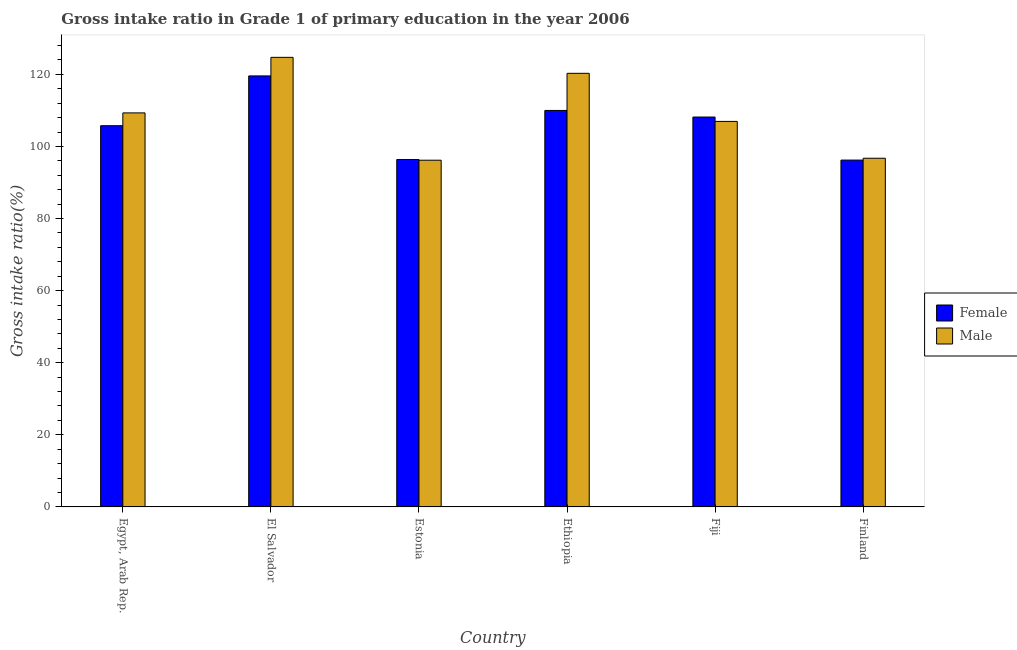How many different coloured bars are there?
Your answer should be very brief. 2. How many groups of bars are there?
Provide a short and direct response. 6. Are the number of bars per tick equal to the number of legend labels?
Provide a succinct answer. Yes. Are the number of bars on each tick of the X-axis equal?
Give a very brief answer. Yes. How many bars are there on the 5th tick from the left?
Offer a terse response. 2. How many bars are there on the 5th tick from the right?
Provide a succinct answer. 2. What is the label of the 1st group of bars from the left?
Give a very brief answer. Egypt, Arab Rep. What is the gross intake ratio(male) in Finland?
Keep it short and to the point. 96.73. Across all countries, what is the maximum gross intake ratio(male)?
Your answer should be very brief. 124.72. Across all countries, what is the minimum gross intake ratio(female)?
Provide a short and direct response. 96.22. In which country was the gross intake ratio(male) maximum?
Your answer should be very brief. El Salvador. In which country was the gross intake ratio(male) minimum?
Offer a very short reply. Estonia. What is the total gross intake ratio(male) in the graph?
Make the answer very short. 654.16. What is the difference between the gross intake ratio(male) in Egypt, Arab Rep. and that in Ethiopia?
Offer a terse response. -10.98. What is the difference between the gross intake ratio(male) in Finland and the gross intake ratio(female) in Egypt, Arab Rep.?
Your response must be concise. -9.03. What is the average gross intake ratio(male) per country?
Offer a terse response. 109.03. What is the difference between the gross intake ratio(female) and gross intake ratio(male) in Ethiopia?
Give a very brief answer. -10.3. In how many countries, is the gross intake ratio(male) greater than 12 %?
Provide a succinct answer. 6. What is the ratio of the gross intake ratio(female) in El Salvador to that in Estonia?
Your answer should be very brief. 1.24. Is the difference between the gross intake ratio(male) in Egypt, Arab Rep. and Estonia greater than the difference between the gross intake ratio(female) in Egypt, Arab Rep. and Estonia?
Your answer should be very brief. Yes. What is the difference between the highest and the second highest gross intake ratio(male)?
Your answer should be very brief. 4.43. What is the difference between the highest and the lowest gross intake ratio(male)?
Offer a very short reply. 28.54. Is the sum of the gross intake ratio(female) in El Salvador and Estonia greater than the maximum gross intake ratio(male) across all countries?
Offer a terse response. Yes. What does the 1st bar from the left in El Salvador represents?
Make the answer very short. Female. How many bars are there?
Your response must be concise. 12. How many countries are there in the graph?
Give a very brief answer. 6. Are the values on the major ticks of Y-axis written in scientific E-notation?
Provide a succinct answer. No. How are the legend labels stacked?
Make the answer very short. Vertical. What is the title of the graph?
Offer a very short reply. Gross intake ratio in Grade 1 of primary education in the year 2006. Does "Borrowers" appear as one of the legend labels in the graph?
Keep it short and to the point. No. What is the label or title of the Y-axis?
Your answer should be compact. Gross intake ratio(%). What is the Gross intake ratio(%) in Female in Egypt, Arab Rep.?
Offer a terse response. 105.75. What is the Gross intake ratio(%) of Male in Egypt, Arab Rep.?
Provide a short and direct response. 109.31. What is the Gross intake ratio(%) in Female in El Salvador?
Offer a very short reply. 119.57. What is the Gross intake ratio(%) in Male in El Salvador?
Offer a terse response. 124.72. What is the Gross intake ratio(%) of Female in Estonia?
Provide a succinct answer. 96.38. What is the Gross intake ratio(%) of Male in Estonia?
Give a very brief answer. 96.18. What is the Gross intake ratio(%) of Female in Ethiopia?
Provide a succinct answer. 109.99. What is the Gross intake ratio(%) of Male in Ethiopia?
Keep it short and to the point. 120.29. What is the Gross intake ratio(%) in Female in Fiji?
Ensure brevity in your answer.  108.16. What is the Gross intake ratio(%) in Male in Fiji?
Give a very brief answer. 106.95. What is the Gross intake ratio(%) in Female in Finland?
Provide a succinct answer. 96.22. What is the Gross intake ratio(%) in Male in Finland?
Your answer should be very brief. 96.73. Across all countries, what is the maximum Gross intake ratio(%) of Female?
Make the answer very short. 119.57. Across all countries, what is the maximum Gross intake ratio(%) of Male?
Offer a very short reply. 124.72. Across all countries, what is the minimum Gross intake ratio(%) in Female?
Keep it short and to the point. 96.22. Across all countries, what is the minimum Gross intake ratio(%) in Male?
Offer a terse response. 96.18. What is the total Gross intake ratio(%) in Female in the graph?
Your answer should be compact. 636.07. What is the total Gross intake ratio(%) in Male in the graph?
Keep it short and to the point. 654.16. What is the difference between the Gross intake ratio(%) of Female in Egypt, Arab Rep. and that in El Salvador?
Provide a short and direct response. -13.81. What is the difference between the Gross intake ratio(%) in Male in Egypt, Arab Rep. and that in El Salvador?
Offer a very short reply. -15.41. What is the difference between the Gross intake ratio(%) of Female in Egypt, Arab Rep. and that in Estonia?
Your answer should be very brief. 9.37. What is the difference between the Gross intake ratio(%) in Male in Egypt, Arab Rep. and that in Estonia?
Ensure brevity in your answer.  13.13. What is the difference between the Gross intake ratio(%) in Female in Egypt, Arab Rep. and that in Ethiopia?
Keep it short and to the point. -4.23. What is the difference between the Gross intake ratio(%) in Male in Egypt, Arab Rep. and that in Ethiopia?
Provide a short and direct response. -10.98. What is the difference between the Gross intake ratio(%) of Female in Egypt, Arab Rep. and that in Fiji?
Give a very brief answer. -2.4. What is the difference between the Gross intake ratio(%) in Male in Egypt, Arab Rep. and that in Fiji?
Give a very brief answer. 2.36. What is the difference between the Gross intake ratio(%) in Female in Egypt, Arab Rep. and that in Finland?
Keep it short and to the point. 9.54. What is the difference between the Gross intake ratio(%) of Male in Egypt, Arab Rep. and that in Finland?
Offer a very short reply. 12.58. What is the difference between the Gross intake ratio(%) in Female in El Salvador and that in Estonia?
Your answer should be compact. 23.19. What is the difference between the Gross intake ratio(%) in Male in El Salvador and that in Estonia?
Keep it short and to the point. 28.54. What is the difference between the Gross intake ratio(%) in Female in El Salvador and that in Ethiopia?
Offer a terse response. 9.58. What is the difference between the Gross intake ratio(%) of Male in El Salvador and that in Ethiopia?
Make the answer very short. 4.43. What is the difference between the Gross intake ratio(%) of Female in El Salvador and that in Fiji?
Keep it short and to the point. 11.41. What is the difference between the Gross intake ratio(%) in Male in El Salvador and that in Fiji?
Offer a terse response. 17.77. What is the difference between the Gross intake ratio(%) of Female in El Salvador and that in Finland?
Your answer should be compact. 23.35. What is the difference between the Gross intake ratio(%) of Male in El Salvador and that in Finland?
Provide a short and direct response. 27.99. What is the difference between the Gross intake ratio(%) in Female in Estonia and that in Ethiopia?
Keep it short and to the point. -13.6. What is the difference between the Gross intake ratio(%) in Male in Estonia and that in Ethiopia?
Give a very brief answer. -24.11. What is the difference between the Gross intake ratio(%) in Female in Estonia and that in Fiji?
Provide a succinct answer. -11.78. What is the difference between the Gross intake ratio(%) of Male in Estonia and that in Fiji?
Make the answer very short. -10.77. What is the difference between the Gross intake ratio(%) of Female in Estonia and that in Finland?
Provide a succinct answer. 0.17. What is the difference between the Gross intake ratio(%) in Male in Estonia and that in Finland?
Make the answer very short. -0.55. What is the difference between the Gross intake ratio(%) of Female in Ethiopia and that in Fiji?
Your answer should be compact. 1.83. What is the difference between the Gross intake ratio(%) in Male in Ethiopia and that in Fiji?
Give a very brief answer. 13.34. What is the difference between the Gross intake ratio(%) of Female in Ethiopia and that in Finland?
Keep it short and to the point. 13.77. What is the difference between the Gross intake ratio(%) of Male in Ethiopia and that in Finland?
Ensure brevity in your answer.  23.56. What is the difference between the Gross intake ratio(%) of Female in Fiji and that in Finland?
Provide a short and direct response. 11.94. What is the difference between the Gross intake ratio(%) of Male in Fiji and that in Finland?
Keep it short and to the point. 10.22. What is the difference between the Gross intake ratio(%) in Female in Egypt, Arab Rep. and the Gross intake ratio(%) in Male in El Salvador?
Provide a short and direct response. -18.96. What is the difference between the Gross intake ratio(%) of Female in Egypt, Arab Rep. and the Gross intake ratio(%) of Male in Estonia?
Make the answer very short. 9.57. What is the difference between the Gross intake ratio(%) in Female in Egypt, Arab Rep. and the Gross intake ratio(%) in Male in Ethiopia?
Your answer should be very brief. -14.53. What is the difference between the Gross intake ratio(%) of Female in Egypt, Arab Rep. and the Gross intake ratio(%) of Male in Fiji?
Ensure brevity in your answer.  -1.19. What is the difference between the Gross intake ratio(%) of Female in Egypt, Arab Rep. and the Gross intake ratio(%) of Male in Finland?
Provide a short and direct response. 9.03. What is the difference between the Gross intake ratio(%) of Female in El Salvador and the Gross intake ratio(%) of Male in Estonia?
Offer a very short reply. 23.39. What is the difference between the Gross intake ratio(%) in Female in El Salvador and the Gross intake ratio(%) in Male in Ethiopia?
Provide a short and direct response. -0.72. What is the difference between the Gross intake ratio(%) of Female in El Salvador and the Gross intake ratio(%) of Male in Fiji?
Your answer should be compact. 12.62. What is the difference between the Gross intake ratio(%) in Female in El Salvador and the Gross intake ratio(%) in Male in Finland?
Ensure brevity in your answer.  22.84. What is the difference between the Gross intake ratio(%) of Female in Estonia and the Gross intake ratio(%) of Male in Ethiopia?
Your answer should be compact. -23.9. What is the difference between the Gross intake ratio(%) of Female in Estonia and the Gross intake ratio(%) of Male in Fiji?
Keep it short and to the point. -10.56. What is the difference between the Gross intake ratio(%) in Female in Estonia and the Gross intake ratio(%) in Male in Finland?
Your response must be concise. -0.35. What is the difference between the Gross intake ratio(%) in Female in Ethiopia and the Gross intake ratio(%) in Male in Fiji?
Offer a very short reply. 3.04. What is the difference between the Gross intake ratio(%) in Female in Ethiopia and the Gross intake ratio(%) in Male in Finland?
Provide a short and direct response. 13.26. What is the difference between the Gross intake ratio(%) of Female in Fiji and the Gross intake ratio(%) of Male in Finland?
Your response must be concise. 11.43. What is the average Gross intake ratio(%) in Female per country?
Provide a short and direct response. 106.01. What is the average Gross intake ratio(%) of Male per country?
Ensure brevity in your answer.  109.03. What is the difference between the Gross intake ratio(%) of Female and Gross intake ratio(%) of Male in Egypt, Arab Rep.?
Ensure brevity in your answer.  -3.55. What is the difference between the Gross intake ratio(%) of Female and Gross intake ratio(%) of Male in El Salvador?
Keep it short and to the point. -5.15. What is the difference between the Gross intake ratio(%) in Female and Gross intake ratio(%) in Male in Estonia?
Your answer should be compact. 0.2. What is the difference between the Gross intake ratio(%) in Female and Gross intake ratio(%) in Male in Ethiopia?
Provide a short and direct response. -10.3. What is the difference between the Gross intake ratio(%) of Female and Gross intake ratio(%) of Male in Fiji?
Give a very brief answer. 1.21. What is the difference between the Gross intake ratio(%) in Female and Gross intake ratio(%) in Male in Finland?
Your response must be concise. -0.51. What is the ratio of the Gross intake ratio(%) in Female in Egypt, Arab Rep. to that in El Salvador?
Offer a terse response. 0.88. What is the ratio of the Gross intake ratio(%) of Male in Egypt, Arab Rep. to that in El Salvador?
Your answer should be very brief. 0.88. What is the ratio of the Gross intake ratio(%) in Female in Egypt, Arab Rep. to that in Estonia?
Keep it short and to the point. 1.1. What is the ratio of the Gross intake ratio(%) of Male in Egypt, Arab Rep. to that in Estonia?
Keep it short and to the point. 1.14. What is the ratio of the Gross intake ratio(%) of Female in Egypt, Arab Rep. to that in Ethiopia?
Give a very brief answer. 0.96. What is the ratio of the Gross intake ratio(%) in Male in Egypt, Arab Rep. to that in Ethiopia?
Offer a very short reply. 0.91. What is the ratio of the Gross intake ratio(%) of Female in Egypt, Arab Rep. to that in Fiji?
Offer a very short reply. 0.98. What is the ratio of the Gross intake ratio(%) of Male in Egypt, Arab Rep. to that in Fiji?
Offer a very short reply. 1.02. What is the ratio of the Gross intake ratio(%) in Female in Egypt, Arab Rep. to that in Finland?
Your response must be concise. 1.1. What is the ratio of the Gross intake ratio(%) of Male in Egypt, Arab Rep. to that in Finland?
Provide a succinct answer. 1.13. What is the ratio of the Gross intake ratio(%) of Female in El Salvador to that in Estonia?
Give a very brief answer. 1.24. What is the ratio of the Gross intake ratio(%) in Male in El Salvador to that in Estonia?
Provide a short and direct response. 1.3. What is the ratio of the Gross intake ratio(%) in Female in El Salvador to that in Ethiopia?
Give a very brief answer. 1.09. What is the ratio of the Gross intake ratio(%) in Male in El Salvador to that in Ethiopia?
Your answer should be compact. 1.04. What is the ratio of the Gross intake ratio(%) in Female in El Salvador to that in Fiji?
Offer a very short reply. 1.11. What is the ratio of the Gross intake ratio(%) of Male in El Salvador to that in Fiji?
Your response must be concise. 1.17. What is the ratio of the Gross intake ratio(%) in Female in El Salvador to that in Finland?
Your answer should be very brief. 1.24. What is the ratio of the Gross intake ratio(%) in Male in El Salvador to that in Finland?
Your response must be concise. 1.29. What is the ratio of the Gross intake ratio(%) of Female in Estonia to that in Ethiopia?
Offer a terse response. 0.88. What is the ratio of the Gross intake ratio(%) in Male in Estonia to that in Ethiopia?
Provide a succinct answer. 0.8. What is the ratio of the Gross intake ratio(%) in Female in Estonia to that in Fiji?
Your answer should be compact. 0.89. What is the ratio of the Gross intake ratio(%) in Male in Estonia to that in Fiji?
Provide a short and direct response. 0.9. What is the ratio of the Gross intake ratio(%) of Female in Ethiopia to that in Fiji?
Make the answer very short. 1.02. What is the ratio of the Gross intake ratio(%) in Male in Ethiopia to that in Fiji?
Your answer should be very brief. 1.12. What is the ratio of the Gross intake ratio(%) of Female in Ethiopia to that in Finland?
Your response must be concise. 1.14. What is the ratio of the Gross intake ratio(%) of Male in Ethiopia to that in Finland?
Make the answer very short. 1.24. What is the ratio of the Gross intake ratio(%) of Female in Fiji to that in Finland?
Provide a short and direct response. 1.12. What is the ratio of the Gross intake ratio(%) in Male in Fiji to that in Finland?
Make the answer very short. 1.11. What is the difference between the highest and the second highest Gross intake ratio(%) in Female?
Make the answer very short. 9.58. What is the difference between the highest and the second highest Gross intake ratio(%) in Male?
Offer a terse response. 4.43. What is the difference between the highest and the lowest Gross intake ratio(%) in Female?
Offer a terse response. 23.35. What is the difference between the highest and the lowest Gross intake ratio(%) of Male?
Keep it short and to the point. 28.54. 